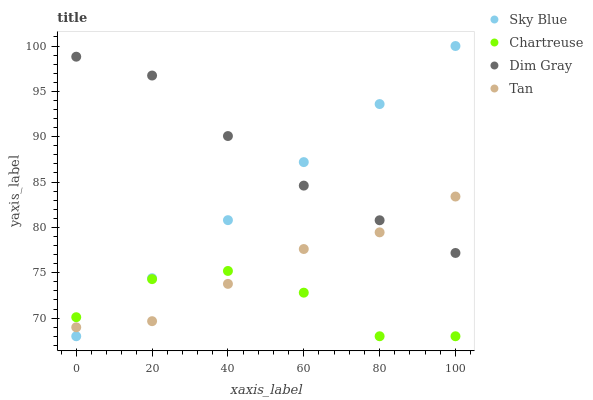Does Chartreuse have the minimum area under the curve?
Answer yes or no. Yes. Does Dim Gray have the maximum area under the curve?
Answer yes or no. Yes. Does Dim Gray have the minimum area under the curve?
Answer yes or no. No. Does Chartreuse have the maximum area under the curve?
Answer yes or no. No. Is Sky Blue the smoothest?
Answer yes or no. Yes. Is Chartreuse the roughest?
Answer yes or no. Yes. Is Dim Gray the smoothest?
Answer yes or no. No. Is Dim Gray the roughest?
Answer yes or no. No. Does Sky Blue have the lowest value?
Answer yes or no. Yes. Does Dim Gray have the lowest value?
Answer yes or no. No. Does Sky Blue have the highest value?
Answer yes or no. Yes. Does Dim Gray have the highest value?
Answer yes or no. No. Is Chartreuse less than Dim Gray?
Answer yes or no. Yes. Is Dim Gray greater than Chartreuse?
Answer yes or no. Yes. Does Tan intersect Sky Blue?
Answer yes or no. Yes. Is Tan less than Sky Blue?
Answer yes or no. No. Is Tan greater than Sky Blue?
Answer yes or no. No. Does Chartreuse intersect Dim Gray?
Answer yes or no. No. 